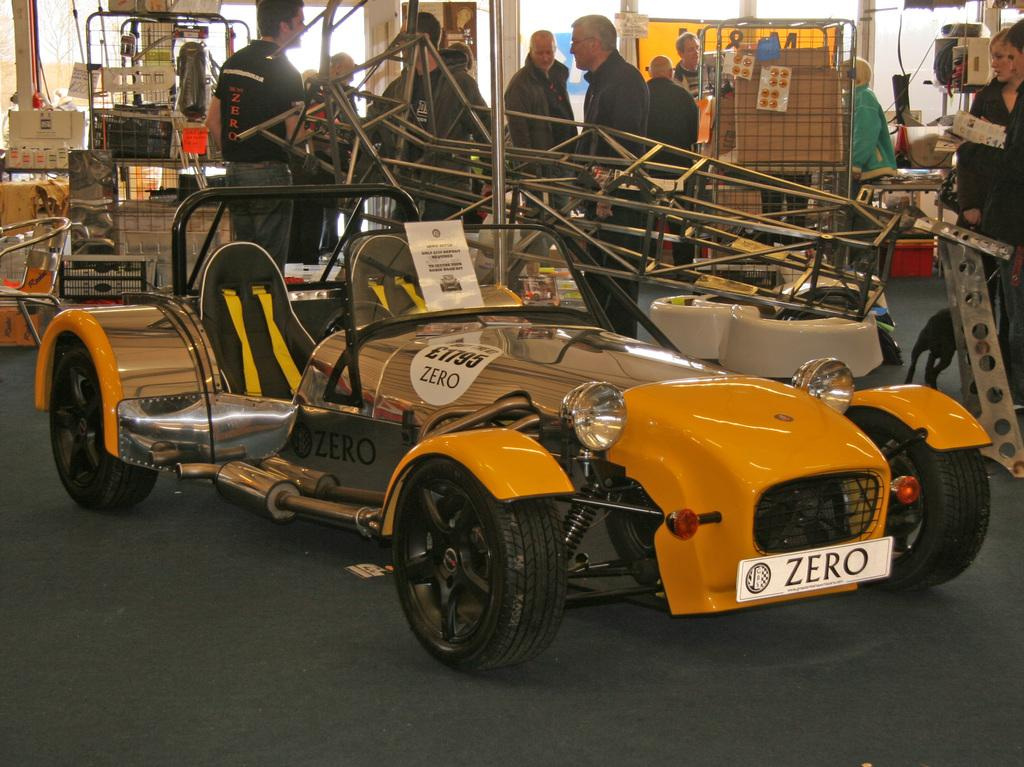What type of vehicle is in the image? There is a vehicle in the image, but the specific type is not mentioned. What colors can be seen on the vehicle? The vehicle has yellow and black colors. What can be seen in the background of the image? There are people, a chair, card-boxes, and objects on the floor in the background. What song is the squirrel singing in the image? There is no squirrel present in the image, and therefore no song can be heard or seen. 